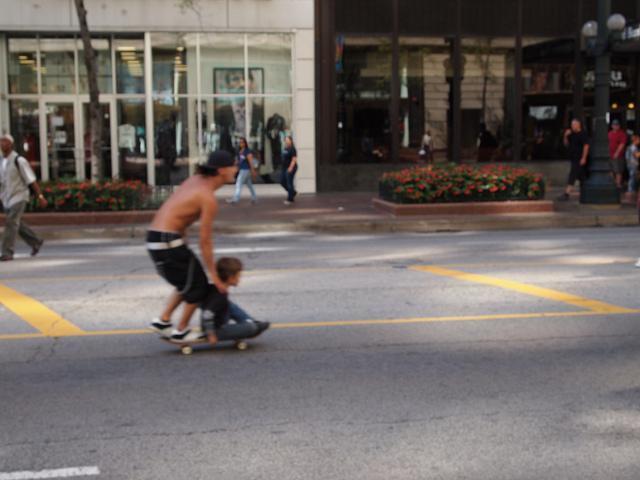How many headlights are visible?
Give a very brief answer. 0. How many skateboarders are not wearing safety equipment?
Give a very brief answer. 2. How many boards are shown?
Give a very brief answer. 1. How many people can you see?
Give a very brief answer. 3. 